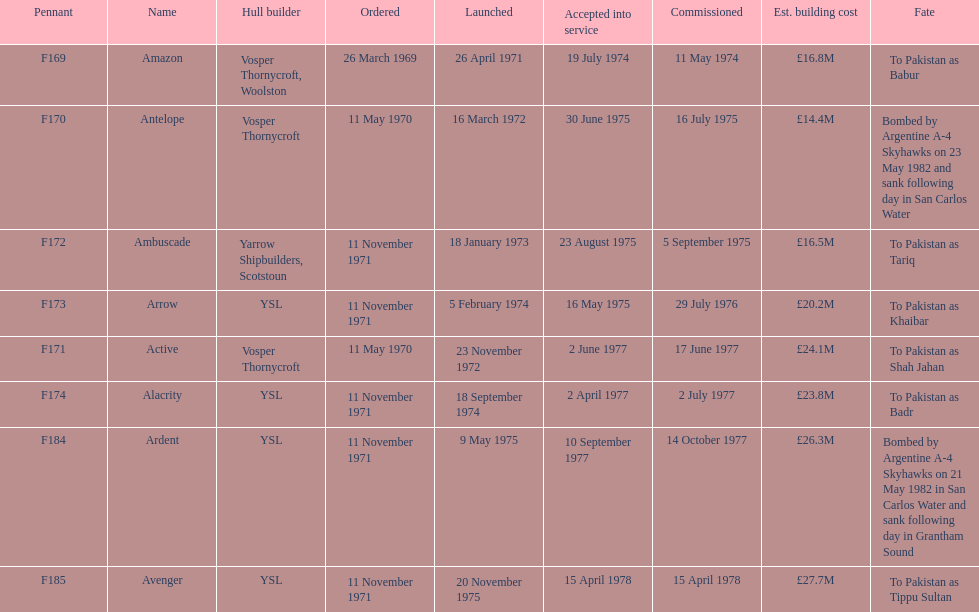Which ship had the highest estimated cost to build? Avenger. 